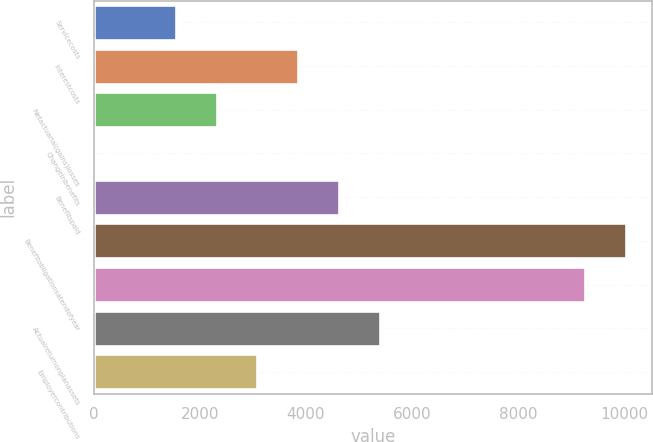<chart> <loc_0><loc_0><loc_500><loc_500><bar_chart><fcel>Servicecosts<fcel>Interestcosts<fcel>Netactuarial(gains)losses<fcel>Changeinbenefits<fcel>Benefitspaid<fcel>Benefitobligationsatendofyear<fcel>Unnamed: 6<fcel>Actualreturnonplanassets<fcel>Employercontributions<nl><fcel>1544.6<fcel>3860<fcel>2316.4<fcel>1<fcel>4631.8<fcel>10034.4<fcel>9262.6<fcel>5403.6<fcel>3088.2<nl></chart> 